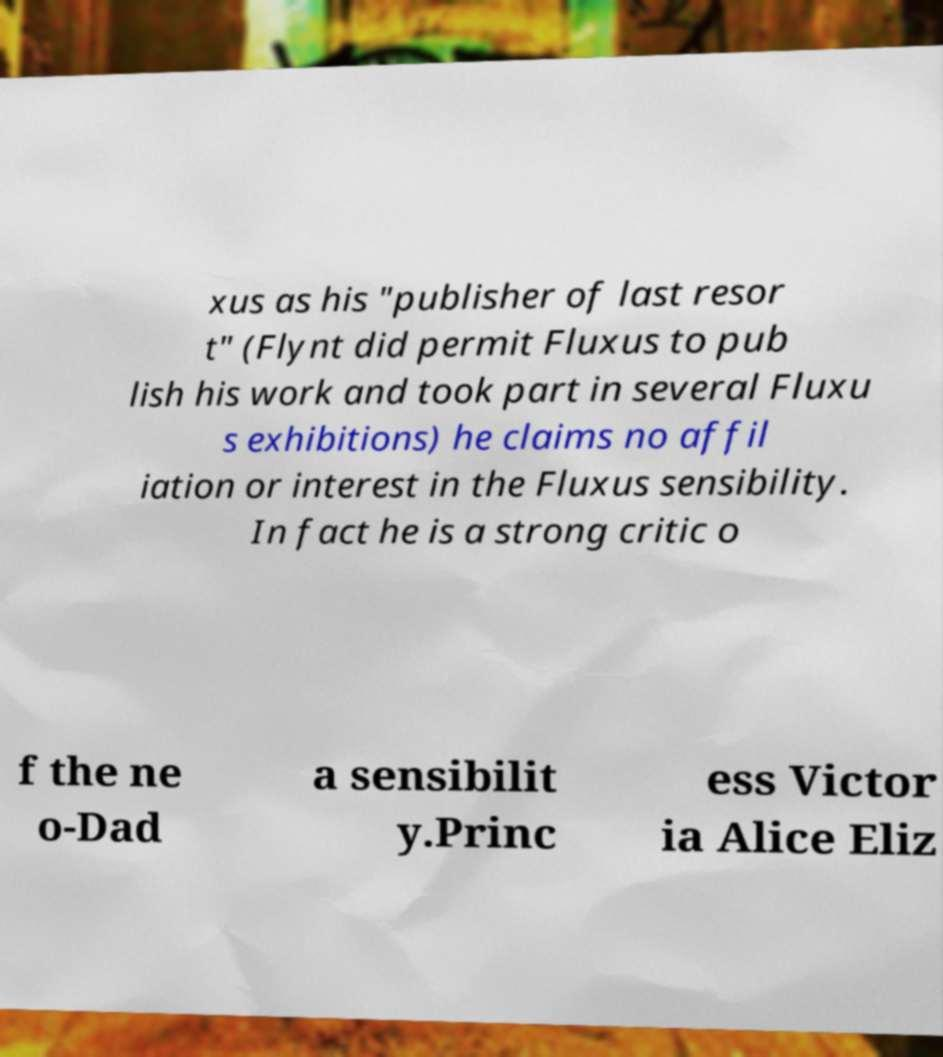There's text embedded in this image that I need extracted. Can you transcribe it verbatim? xus as his "publisher of last resor t" (Flynt did permit Fluxus to pub lish his work and took part in several Fluxu s exhibitions) he claims no affil iation or interest in the Fluxus sensibility. In fact he is a strong critic o f the ne o-Dad a sensibilit y.Princ ess Victor ia Alice Eliz 